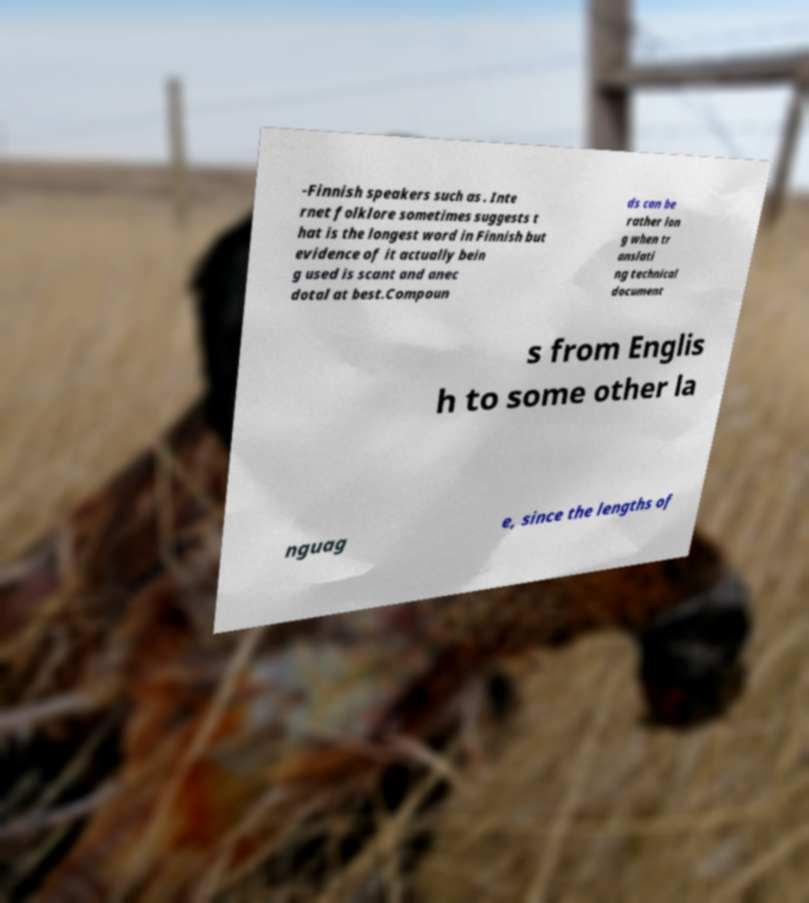Could you assist in decoding the text presented in this image and type it out clearly? -Finnish speakers such as . Inte rnet folklore sometimes suggests t hat is the longest word in Finnish but evidence of it actually bein g used is scant and anec dotal at best.Compoun ds can be rather lon g when tr anslati ng technical document s from Englis h to some other la nguag e, since the lengths of 